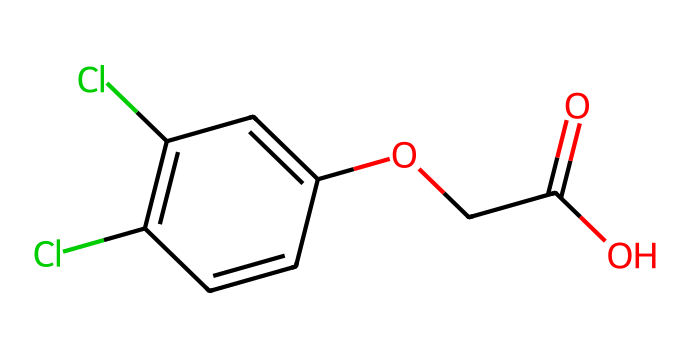How many chlorine atoms are present in the structure? By examining the SMILES representation, "ClC1=C(Cl)", we can identify two occurrences of the "Cl" symbol, each representing a chlorine atom. Therefore, there are two chlorine atoms.
Answer: 2 What is the main functional group present in this herbicide? The SMILES notation "OCC(=O)O" indicates the presence of a carboxylic acid functional group, characterized by the "C(=O)O" part, which signifies a carbon atom double-bonded to an oxygen atom and single-bonded to a hydroxyl group.
Answer: carboxylic acid How many carbon atoms are in the molecule? Counting the carbon atoms in the SMILES, there are a total of 8 carbon atoms represented in the entire structure.
Answer: 8 Which part of the structure indicates that it is an herbicide? The presence of the chlorinated aromatic ring and the carboxylic acid functional group suggest its herbicidal properties. The combination of chlorine atoms and the structural arrangement allows it to inhibit the growth of certain plants, making it a herbicide.
Answer: chlorinated aromatic ring What is the molecular weight of 2,4-Dichlorophenoxyacetic acid? Using the chemical formula derived from the structure (C8H6Cl2O3) and calculating based on typical atomic weights of carbon (12), hydrogen (1), chlorine (35.5), and oxygen (16), we determine that the molecular weight is approximately 221 grams per mole.
Answer: 221 g/mol 